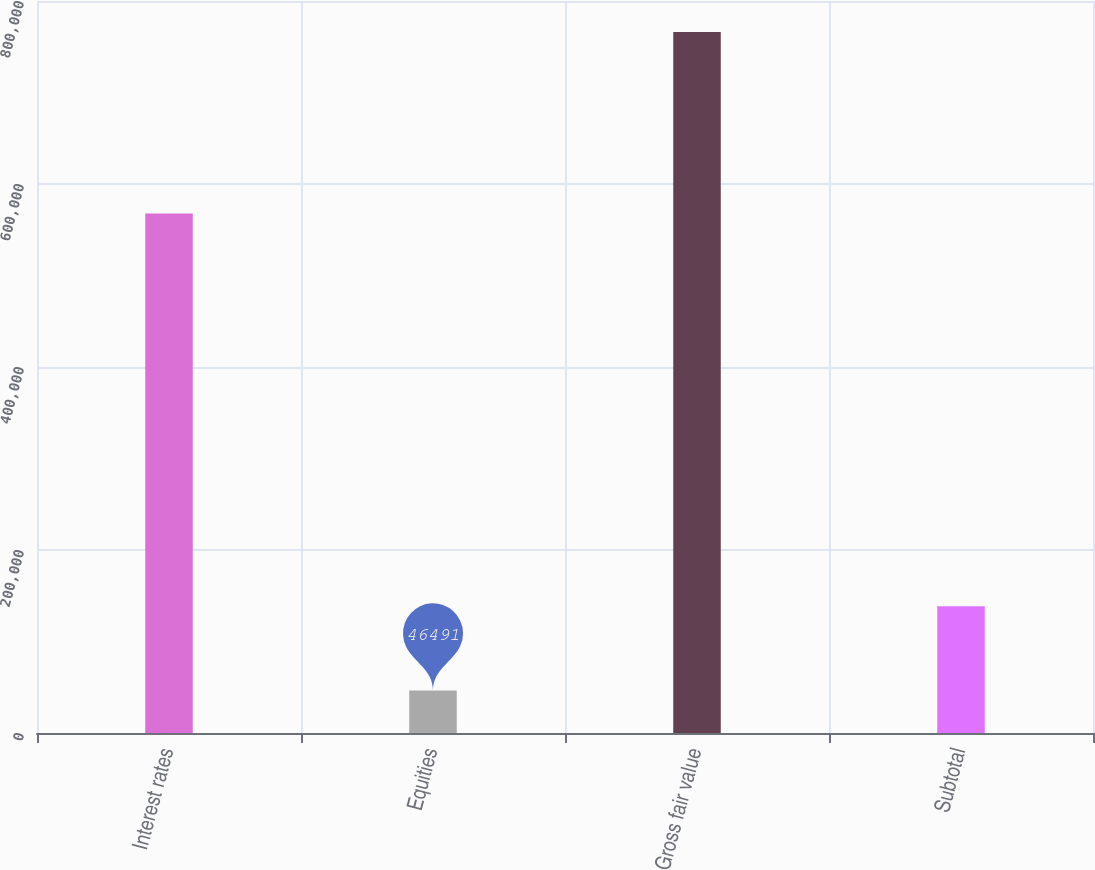<chart> <loc_0><loc_0><loc_500><loc_500><bar_chart><fcel>Interest rates<fcel>Equities<fcel>Gross fair value<fcel>Subtotal<nl><fcel>567761<fcel>46491<fcel>766130<fcel>138582<nl></chart> 